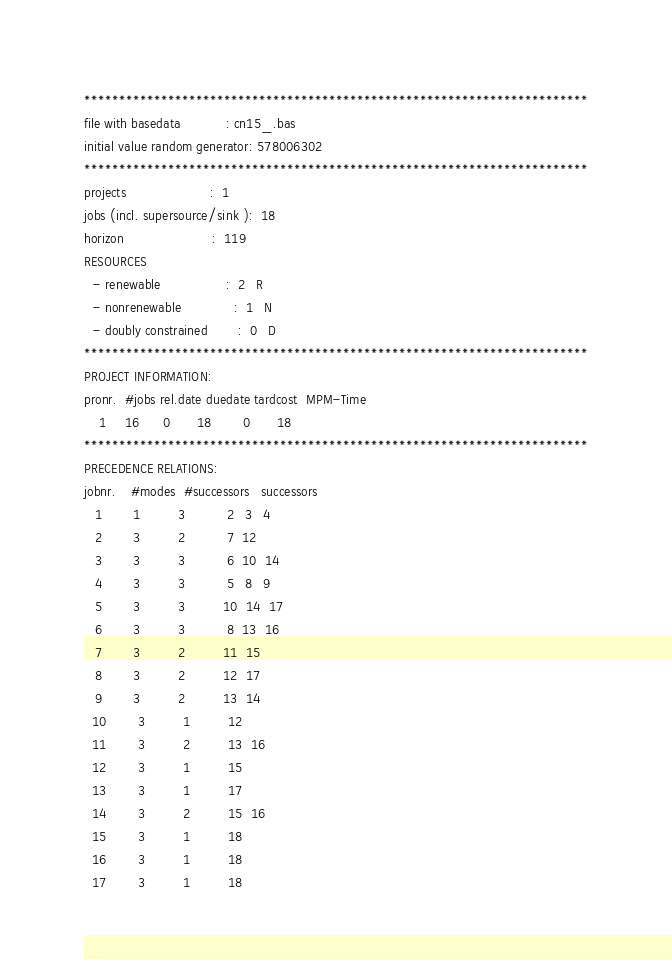<code> <loc_0><loc_0><loc_500><loc_500><_ObjectiveC_>************************************************************************
file with basedata            : cn15_.bas
initial value random generator: 578006302
************************************************************************
projects                      :  1
jobs (incl. supersource/sink ):  18
horizon                       :  119
RESOURCES
  - renewable                 :  2   R
  - nonrenewable              :  1   N
  - doubly constrained        :  0   D
************************************************************************
PROJECT INFORMATION:
pronr.  #jobs rel.date duedate tardcost  MPM-Time
    1     16      0       18        0       18
************************************************************************
PRECEDENCE RELATIONS:
jobnr.    #modes  #successors   successors
   1        1          3           2   3   4
   2        3          2           7  12
   3        3          3           6  10  14
   4        3          3           5   8   9
   5        3          3          10  14  17
   6        3          3           8  13  16
   7        3          2          11  15
   8        3          2          12  17
   9        3          2          13  14
  10        3          1          12
  11        3          2          13  16
  12        3          1          15
  13        3          1          17
  14        3          2          15  16
  15        3          1          18
  16        3          1          18
  17        3          1          18</code> 